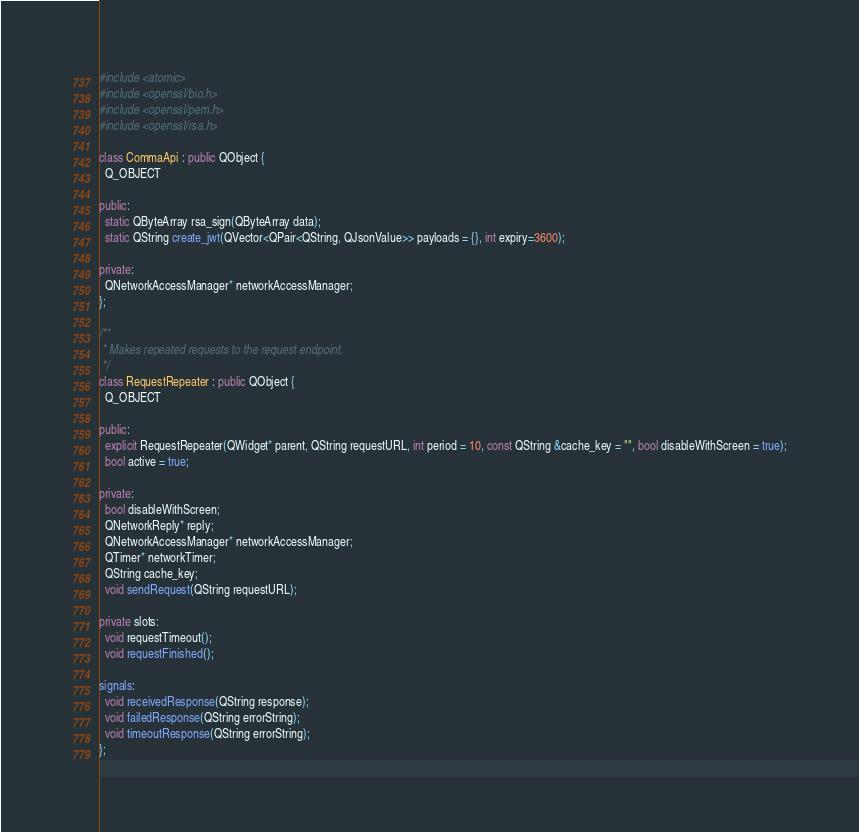<code> <loc_0><loc_0><loc_500><loc_500><_C++_>
#include <atomic>
#include <openssl/bio.h>
#include <openssl/pem.h>
#include <openssl/rsa.h>

class CommaApi : public QObject {
  Q_OBJECT

public:
  static QByteArray rsa_sign(QByteArray data);
  static QString create_jwt(QVector<QPair<QString, QJsonValue>> payloads = {}, int expiry=3600);

private:
  QNetworkAccessManager* networkAccessManager;
};

/**
 * Makes repeated requests to the request endpoint.
 */
class RequestRepeater : public QObject {
  Q_OBJECT

public:
  explicit RequestRepeater(QWidget* parent, QString requestURL, int period = 10, const QString &cache_key = "", bool disableWithScreen = true);
  bool active = true;

private:
  bool disableWithScreen;
  QNetworkReply* reply;
  QNetworkAccessManager* networkAccessManager;
  QTimer* networkTimer;
  QString cache_key;
  void sendRequest(QString requestURL);

private slots:
  void requestTimeout();
  void requestFinished();

signals:
  void receivedResponse(QString response);
  void failedResponse(QString errorString);
  void timeoutResponse(QString errorString);
};
</code> 